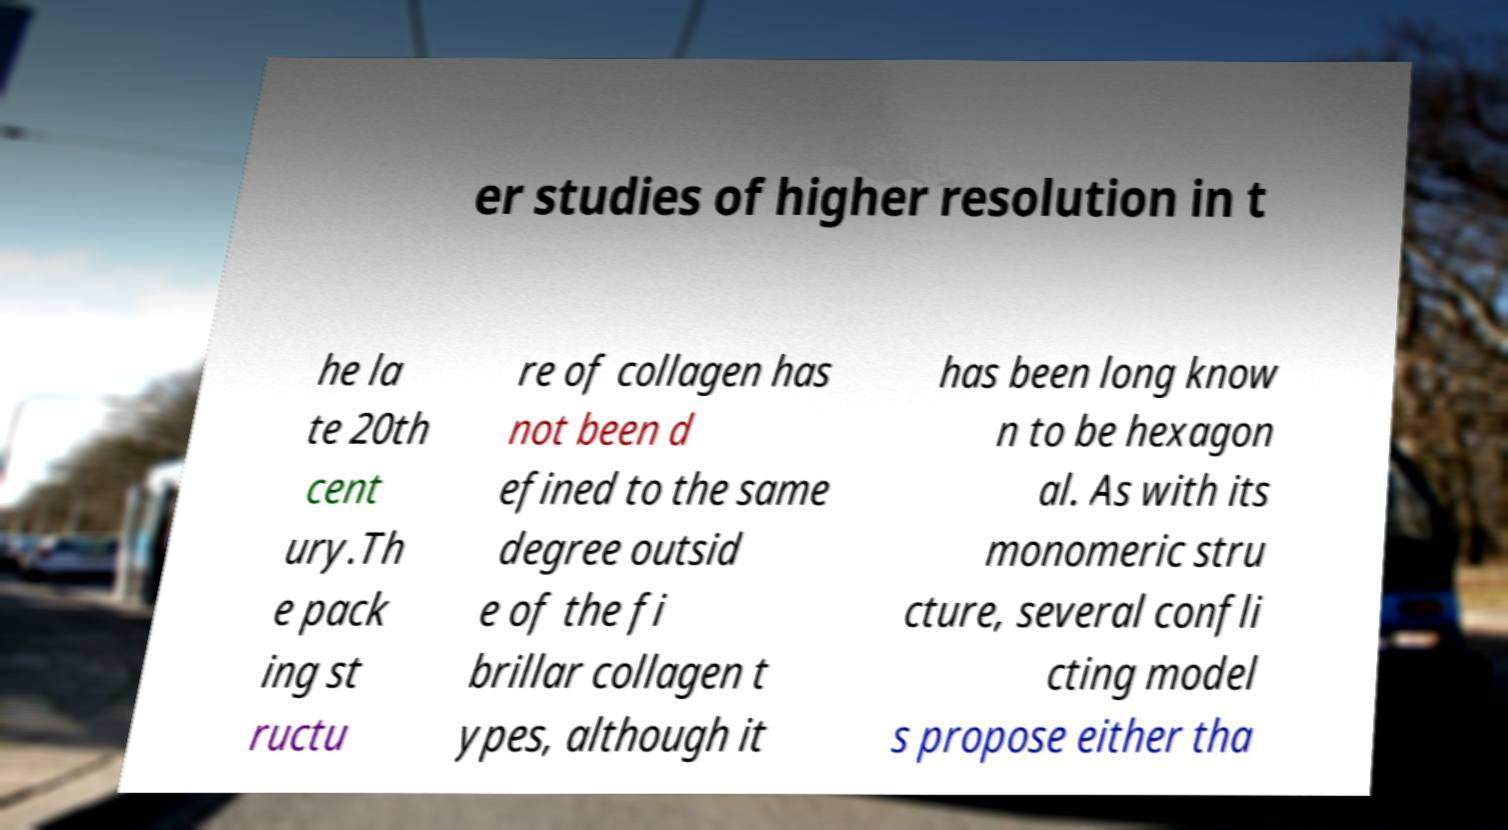I need the written content from this picture converted into text. Can you do that? er studies of higher resolution in t he la te 20th cent ury.Th e pack ing st ructu re of collagen has not been d efined to the same degree outsid e of the fi brillar collagen t ypes, although it has been long know n to be hexagon al. As with its monomeric stru cture, several confli cting model s propose either tha 